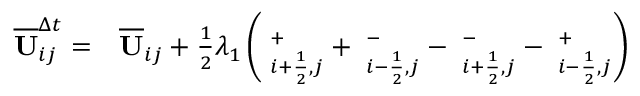Convert formula to latex. <formula><loc_0><loc_0><loc_500><loc_500>\begin{array} { r l } { \overline { U } _ { i j } ^ { \Delta t } = } & \overline { U } _ { i j } + \frac { 1 } { 2 } \lambda _ { 1 } \left ( { \Pi } _ { i + \frac { 1 } { 2 } , j } ^ { + } + { \Pi } _ { i - \frac { 1 } { 2 } , j } ^ { - } - { \Pi } _ { i + \frac { 1 } { 2 } , j } ^ { - } - { \Pi } _ { i - \frac { 1 } { 2 } , j } ^ { + } \right ) } \end{array}</formula> 